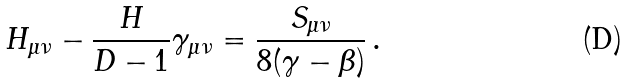<formula> <loc_0><loc_0><loc_500><loc_500>H _ { \mu \nu } - \frac { H } { D - 1 } \gamma _ { \mu \nu } = \frac { S _ { \mu \nu } } { 8 ( \gamma - \beta ) } \, .</formula> 